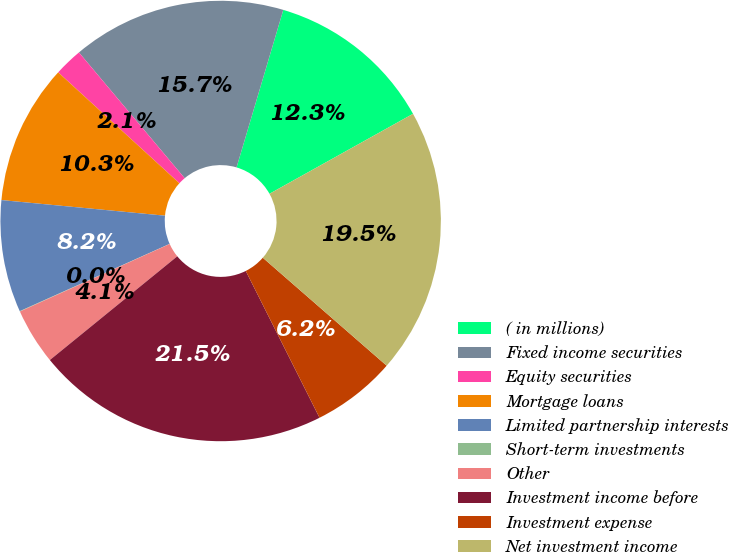Convert chart to OTSL. <chart><loc_0><loc_0><loc_500><loc_500><pie_chart><fcel>( in millions)<fcel>Fixed income securities<fcel>Equity securities<fcel>Mortgage loans<fcel>Limited partnership interests<fcel>Short-term investments<fcel>Other<fcel>Investment income before<fcel>Investment expense<fcel>Net investment income<nl><fcel>12.32%<fcel>15.72%<fcel>2.08%<fcel>10.28%<fcel>8.23%<fcel>0.03%<fcel>4.13%<fcel>21.54%<fcel>6.18%<fcel>19.5%<nl></chart> 